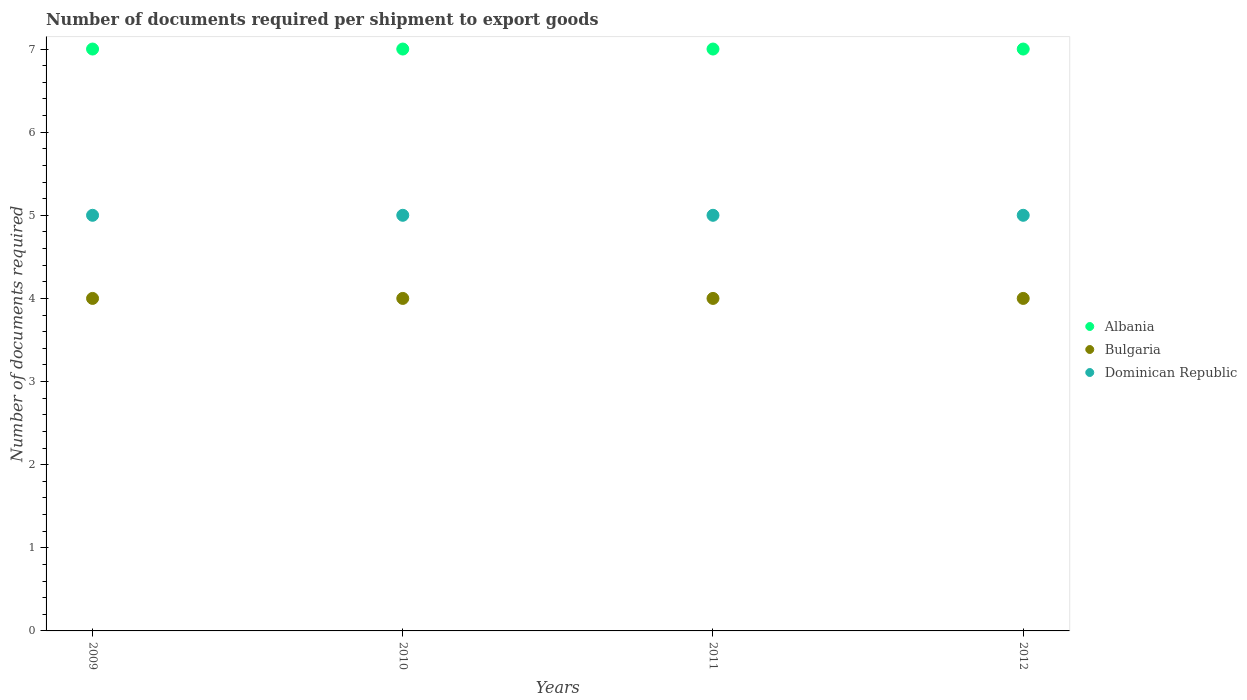What is the number of documents required per shipment to export goods in Dominican Republic in 2009?
Your answer should be very brief. 5. Across all years, what is the maximum number of documents required per shipment to export goods in Bulgaria?
Your answer should be very brief. 4. Across all years, what is the minimum number of documents required per shipment to export goods in Bulgaria?
Your answer should be compact. 4. In which year was the number of documents required per shipment to export goods in Bulgaria maximum?
Your response must be concise. 2009. What is the total number of documents required per shipment to export goods in Dominican Republic in the graph?
Give a very brief answer. 20. What is the difference between the number of documents required per shipment to export goods in Bulgaria in 2009 and that in 2011?
Your answer should be very brief. 0. What is the difference between the number of documents required per shipment to export goods in Bulgaria in 2011 and the number of documents required per shipment to export goods in Dominican Republic in 2012?
Ensure brevity in your answer.  -1. What is the average number of documents required per shipment to export goods in Bulgaria per year?
Your response must be concise. 4. In the year 2012, what is the difference between the number of documents required per shipment to export goods in Albania and number of documents required per shipment to export goods in Bulgaria?
Offer a very short reply. 3. In how many years, is the number of documents required per shipment to export goods in Bulgaria greater than 2.8?
Provide a succinct answer. 4. Is the difference between the number of documents required per shipment to export goods in Albania in 2010 and 2011 greater than the difference between the number of documents required per shipment to export goods in Bulgaria in 2010 and 2011?
Ensure brevity in your answer.  No. In how many years, is the number of documents required per shipment to export goods in Dominican Republic greater than the average number of documents required per shipment to export goods in Dominican Republic taken over all years?
Ensure brevity in your answer.  0. Is the sum of the number of documents required per shipment to export goods in Bulgaria in 2010 and 2011 greater than the maximum number of documents required per shipment to export goods in Albania across all years?
Ensure brevity in your answer.  Yes. Does the number of documents required per shipment to export goods in Bulgaria monotonically increase over the years?
Ensure brevity in your answer.  No. Is the number of documents required per shipment to export goods in Albania strictly greater than the number of documents required per shipment to export goods in Bulgaria over the years?
Make the answer very short. Yes. What is the difference between two consecutive major ticks on the Y-axis?
Make the answer very short. 1. Are the values on the major ticks of Y-axis written in scientific E-notation?
Your answer should be compact. No. Does the graph contain any zero values?
Make the answer very short. No. How many legend labels are there?
Keep it short and to the point. 3. How are the legend labels stacked?
Give a very brief answer. Vertical. What is the title of the graph?
Make the answer very short. Number of documents required per shipment to export goods. What is the label or title of the Y-axis?
Your answer should be compact. Number of documents required. What is the Number of documents required in Albania in 2011?
Ensure brevity in your answer.  7. What is the Number of documents required of Bulgaria in 2011?
Your response must be concise. 4. What is the Number of documents required of Dominican Republic in 2011?
Make the answer very short. 5. What is the Number of documents required of Dominican Republic in 2012?
Your answer should be very brief. 5. Across all years, what is the maximum Number of documents required in Dominican Republic?
Keep it short and to the point. 5. What is the difference between the Number of documents required in Bulgaria in 2009 and that in 2010?
Provide a succinct answer. 0. What is the difference between the Number of documents required of Dominican Republic in 2009 and that in 2010?
Your answer should be very brief. 0. What is the difference between the Number of documents required of Albania in 2009 and that in 2012?
Provide a short and direct response. 0. What is the difference between the Number of documents required in Dominican Republic in 2010 and that in 2011?
Ensure brevity in your answer.  0. What is the difference between the Number of documents required of Albania in 2011 and that in 2012?
Make the answer very short. 0. What is the difference between the Number of documents required of Bulgaria in 2011 and that in 2012?
Provide a succinct answer. 0. What is the difference between the Number of documents required of Albania in 2009 and the Number of documents required of Dominican Republic in 2010?
Make the answer very short. 2. What is the difference between the Number of documents required in Bulgaria in 2009 and the Number of documents required in Dominican Republic in 2010?
Keep it short and to the point. -1. What is the difference between the Number of documents required of Albania in 2009 and the Number of documents required of Dominican Republic in 2011?
Your answer should be very brief. 2. What is the difference between the Number of documents required of Albania in 2009 and the Number of documents required of Dominican Republic in 2012?
Make the answer very short. 2. What is the difference between the Number of documents required of Bulgaria in 2009 and the Number of documents required of Dominican Republic in 2012?
Give a very brief answer. -1. What is the difference between the Number of documents required in Albania in 2010 and the Number of documents required in Dominican Republic in 2011?
Keep it short and to the point. 2. What is the difference between the Number of documents required of Albania in 2010 and the Number of documents required of Bulgaria in 2012?
Ensure brevity in your answer.  3. What is the difference between the Number of documents required in Albania in 2011 and the Number of documents required in Dominican Republic in 2012?
Provide a succinct answer. 2. What is the average Number of documents required in Albania per year?
Your response must be concise. 7. What is the average Number of documents required of Dominican Republic per year?
Give a very brief answer. 5. In the year 2009, what is the difference between the Number of documents required in Albania and Number of documents required in Bulgaria?
Give a very brief answer. 3. In the year 2010, what is the difference between the Number of documents required in Albania and Number of documents required in Bulgaria?
Provide a succinct answer. 3. In the year 2010, what is the difference between the Number of documents required in Albania and Number of documents required in Dominican Republic?
Your answer should be very brief. 2. In the year 2010, what is the difference between the Number of documents required of Bulgaria and Number of documents required of Dominican Republic?
Ensure brevity in your answer.  -1. In the year 2011, what is the difference between the Number of documents required of Albania and Number of documents required of Dominican Republic?
Provide a succinct answer. 2. In the year 2012, what is the difference between the Number of documents required in Albania and Number of documents required in Bulgaria?
Make the answer very short. 3. In the year 2012, what is the difference between the Number of documents required of Bulgaria and Number of documents required of Dominican Republic?
Provide a short and direct response. -1. What is the ratio of the Number of documents required of Albania in 2009 to that in 2010?
Ensure brevity in your answer.  1. What is the ratio of the Number of documents required of Bulgaria in 2009 to that in 2010?
Keep it short and to the point. 1. What is the ratio of the Number of documents required in Albania in 2009 to that in 2011?
Offer a very short reply. 1. What is the ratio of the Number of documents required of Albania in 2009 to that in 2012?
Keep it short and to the point. 1. What is the ratio of the Number of documents required in Dominican Republic in 2009 to that in 2012?
Your response must be concise. 1. What is the ratio of the Number of documents required in Bulgaria in 2010 to that in 2011?
Ensure brevity in your answer.  1. What is the ratio of the Number of documents required in Albania in 2011 to that in 2012?
Your answer should be very brief. 1. What is the ratio of the Number of documents required of Dominican Republic in 2011 to that in 2012?
Your response must be concise. 1. What is the difference between the highest and the lowest Number of documents required of Bulgaria?
Ensure brevity in your answer.  0. 